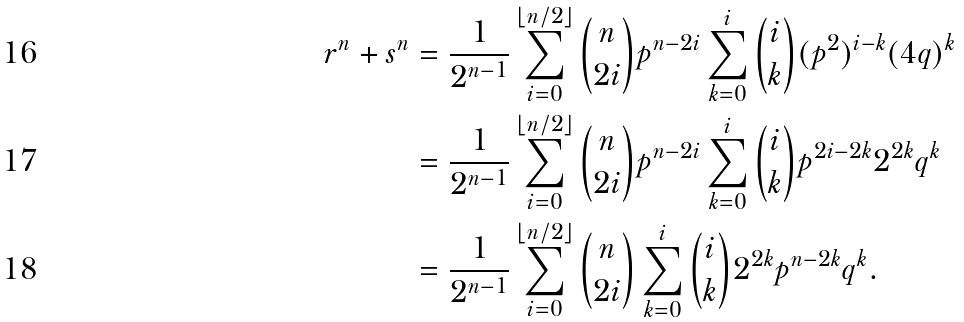<formula> <loc_0><loc_0><loc_500><loc_500>r ^ { n } + s ^ { n } & = \frac { 1 } { 2 ^ { n - 1 } } \sum _ { i = 0 } ^ { \lfloor n / 2 \rfloor } \binom { n } { 2 i } p ^ { n - 2 i } \sum _ { k = 0 } ^ { i } \binom { i } { k } ( p ^ { 2 } ) ^ { i - k } ( 4 q ) ^ { k } \\ & = \frac { 1 } { 2 ^ { n - 1 } } \sum _ { i = 0 } ^ { \lfloor n / 2 \rfloor } \binom { n } { 2 i } p ^ { n - 2 i } \sum _ { k = 0 } ^ { i } \binom { i } { k } p ^ { 2 i - 2 k } 2 ^ { 2 k } q ^ { k } \\ & = \frac { 1 } { 2 ^ { n - 1 } } \sum _ { i = 0 } ^ { \lfloor n / 2 \rfloor } \binom { n } { 2 i } \sum _ { k = 0 } ^ { i } \binom { i } { k } 2 ^ { 2 k } p ^ { n - 2 k } q ^ { k } .</formula> 